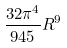Convert formula to latex. <formula><loc_0><loc_0><loc_500><loc_500>\frac { 3 2 \pi ^ { 4 } } { 9 4 5 } R ^ { 9 }</formula> 